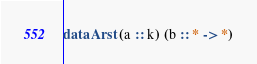Convert code to text. <code><loc_0><loc_0><loc_500><loc_500><_Haskell_>
data Arst (a :: k) (b :: * -> *)
</code> 